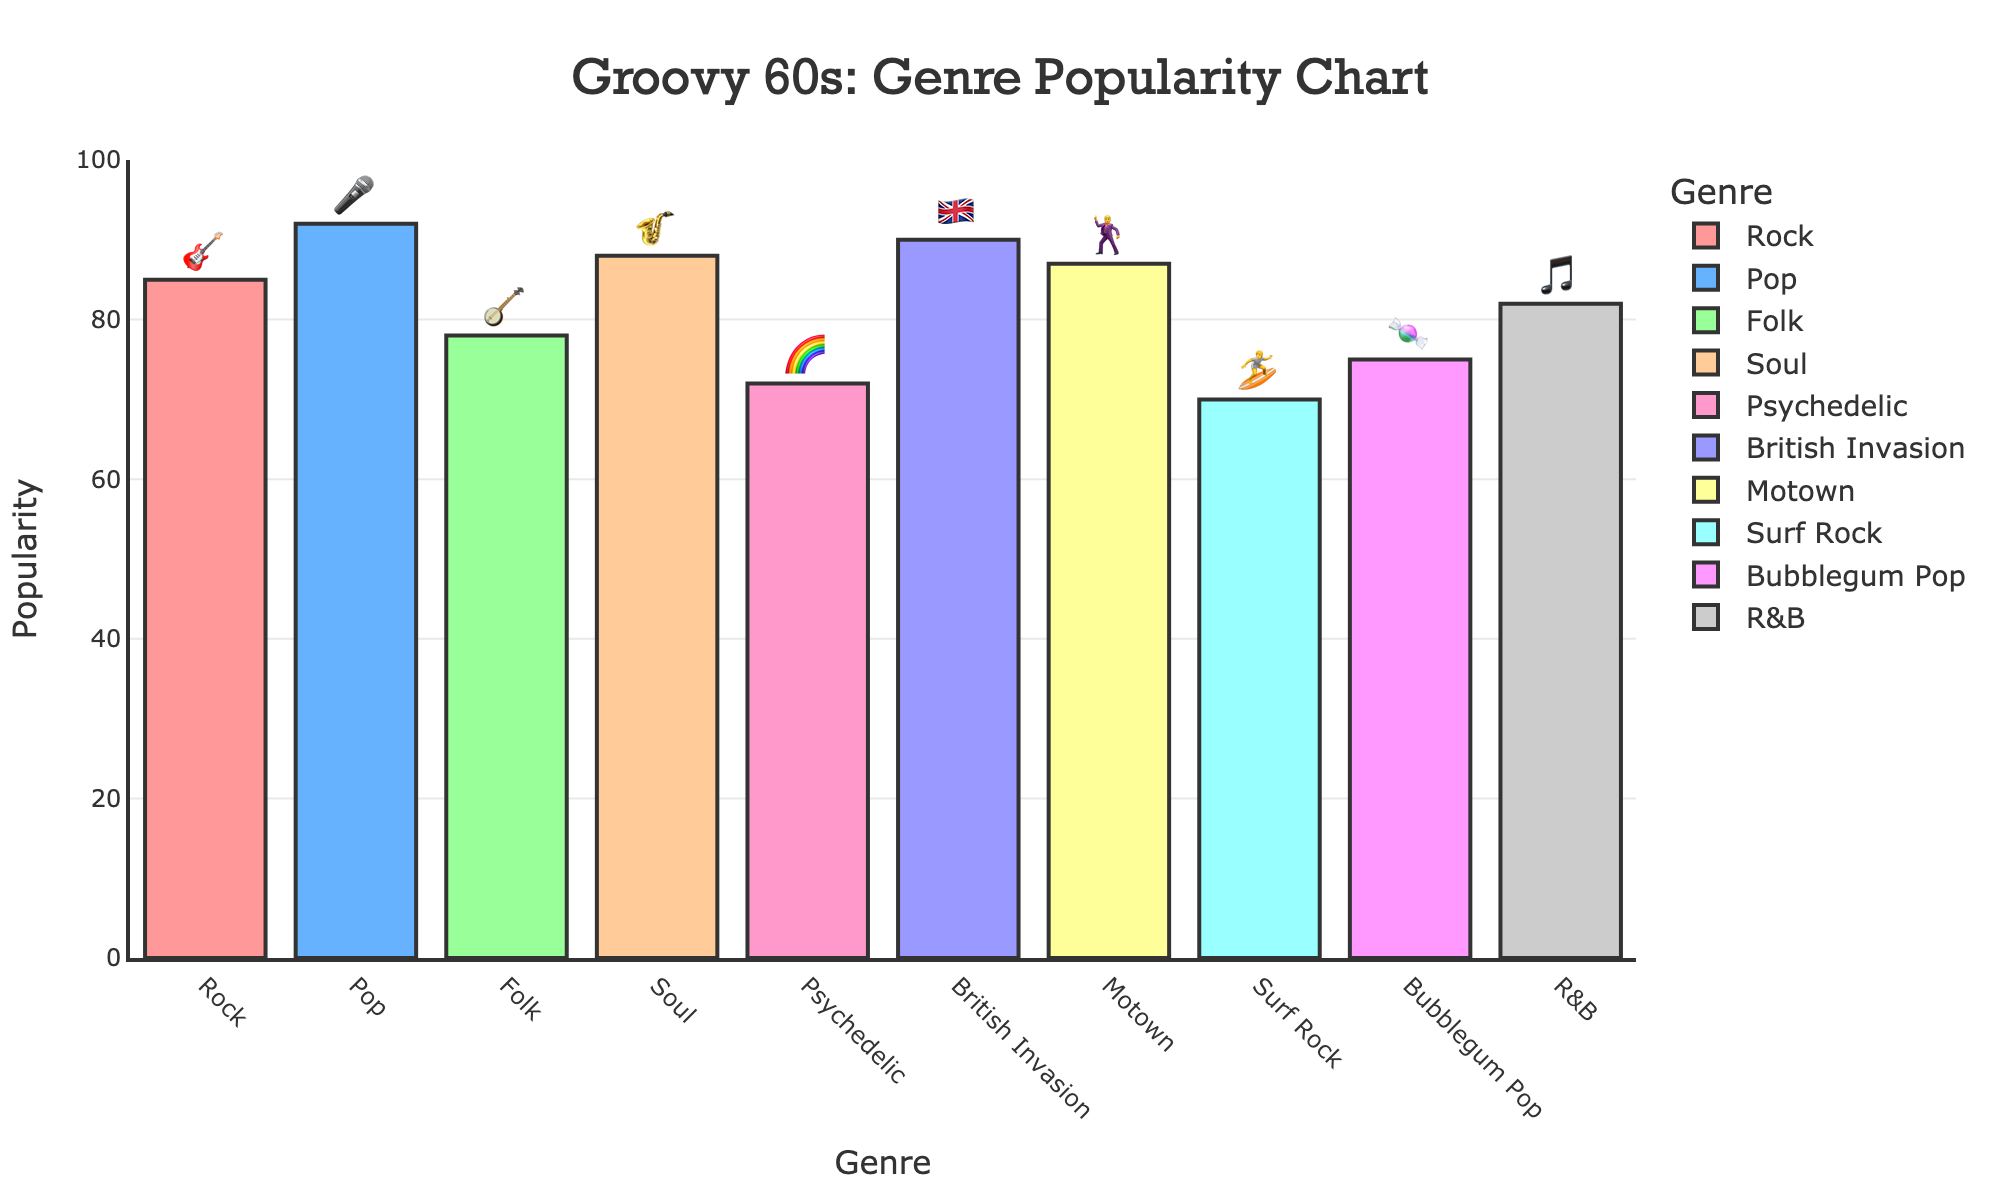What's the most popular genre according to the chart? The highest bar on the chart represents the most popular genre. By looking at the bar heights, the Pop genre (🎤) has the highest popularity score at 92.
Answer: Pop 🎤 Which genre has the lowest popularity score? The smallest bar on the chart represents the least popular genre. By inspecting the chart, the Surf Rock genre (🏄) has the lowest popularity score at 70.
Answer: Surf Rock 🏄 How much more popular is Pop compared to Folk? To find the difference, subtract the popularity score of Folk (78) from that of Pop (92). 92 - 78 = 14.
Answer: 14 Which genres have a popularity score greater than 80? Inspecting the chart, the genres with popularity scores greater than 80 are Rock (85), Pop (92), Soul (88), British Invasion (90), Motown (87), and R&B (82).
Answer: Rock, Pop, Soul, British Invasion, Motown, R&B What's the average popularity of all the genres combined? Sum all the popularity scores and divide by the number of genres: (85 + 92 + 78 + 88 + 72 + 90 + 87 + 70 + 75 + 82)/10 = 81.9.
Answer: 81.9 What's the sum of the popularity scores for Rock, Soul, and R&B? Add the popularity scores for these genres: 85 (Rock) + 88 (Soul) + 82 (R&B) = 255.
Answer: 255 Which genre has a popularity closest to 80? By looking at the bar heights, immediately, you can see that Folk (78) and R&B (82) are closest to 80. Among these, Folk (78) is closest.
Answer: Folk 🪕 Are there more genres with popularity scores above or below 80? Count the bars above and below 80:
Above: Rock, Pop, Soul, British Invasion, Motown, R&B (6 genres).
Below: Folk, Psychedelic, Surf Rock, Bubblegum Pop (4 genres).
There are more genres with popularity scores above 80.
Answer: Above Which genre has a popularity score of 75? By examining the bars, Bubblegum Pop (🍬) has a popularity score of 75.
Answer: Bubblegum Pop 🍬 